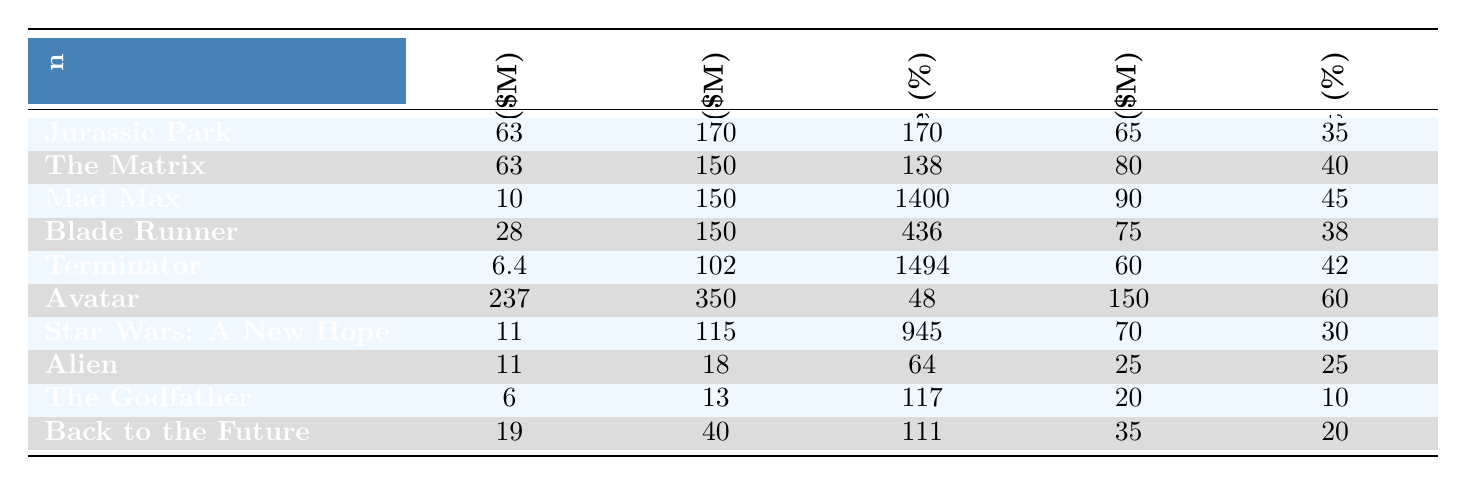What is the original budget for "Avatar"? The original budget for "Avatar" is listed directly in the table. Referring to the "Original Budget ($M)" column for "Avatar," we see that it is 237 million dollars.
Answer: 237 Which sequel had the highest budget increase percentage? To find the highest budget increase percentage, we look at the "Budget Increase (%)" column. The maximum value in this column is 1494%, corresponding to "Terminator."
Answer: Terminator What is the marketing budget for "Mad Max"? The marketing budget for "Mad Max" can be found in the "Marketing Budget ($M)" column. The value listed there is 90 million dollars.
Answer: 90 What is the difference between the original and sequel budget for "The Godfather"? We find the original budget for "The Godfather" is 6 million, and the sequel budget is 13 million. The difference is calculated as: 13 - 6 = 7 million dollars.
Answer: 7 How many million dollars was spent on special effects for "Blade Runner"? The special effects budget is given as a percentage. For "Blade Runner," it is 38%. To know the actual expenditure, we calculate 38% of the sequel budget (150 million), which is: 0.38 * 150 = 57 million dollars.
Answer: 57 Is the marketing budget for "Jurassic Park" higher than 70 million dollars? The marketing budget for "Jurassic Park" is given as 65 million dollars. Therefore, it is not higher than 70 million dollars.
Answer: No What is the average original budget for the films listed? First, we sum the original budgets: 63 + 63 + 10 + 28 + 6.4 + 237 + 11 + 11 + 6 + 19 = 446.4 million dollars. There are 10 films, so we calculate the average as: 446.4 / 10 = 44.64 million dollars.
Answer: 44.64 Which film has the highest marketing budget and what is that amount? By checking the "Marketing Budget ($M)" column, we can see that "Avatar" has the highest marketing budget of 150 million dollars.
Answer: Avatar, 150 What is the relationship between budget increase and special effects budget for "The Matrix"? For "The Matrix," the budget increase percentage is 138%, and the special effects budget percentage is 40%. This means that the film had a substantial increase in budget and also allocated a significant amount to special effects, indicating a correlation between higher expenditures and perceived need for quality effects.
Answer: High correlation Which sequel has the lowest original budget? By reviewing the "Original Budget ($M)" column, "Terminator" has the lowest original budget of 6.4 million dollars.
Answer: Terminator 